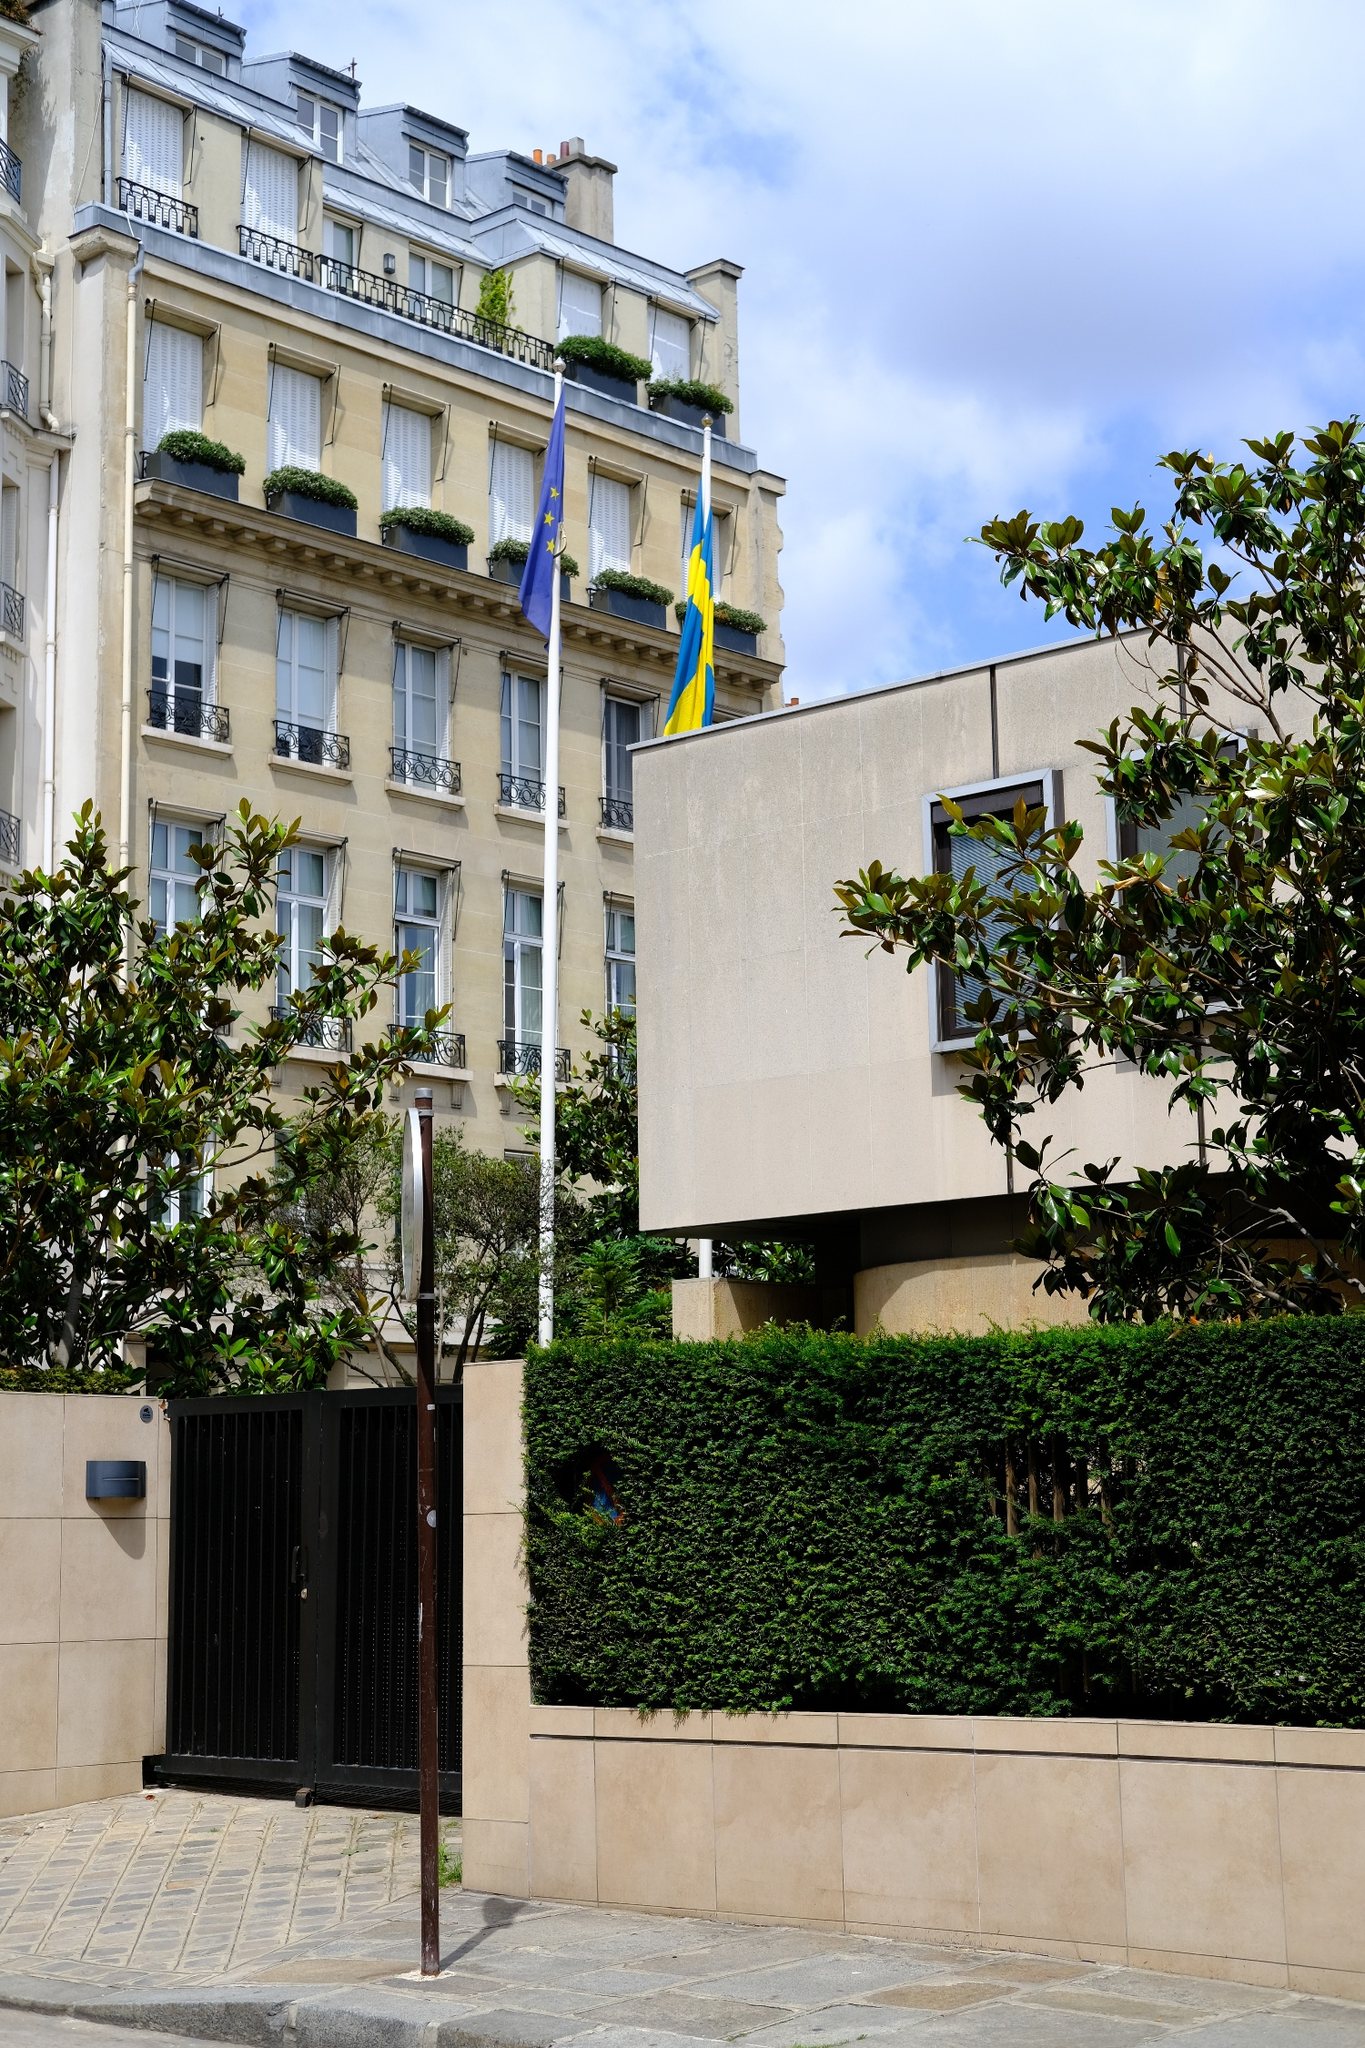Create a short, vivid story involving a character interacting with this building. Amelia had always been intrigued by the elegant beige building she passed on her way to the university every morning. Today, clutching a mysterious letter she found slipped under her door, she felt drawn to it more than ever. The building, always flanked by the fluttering European Union and Swedish flags, seemed to beckon her. As she approached the ornate gate, an elderly man with a twinkling eye greeted her as if he had known her all her life. He explained that she had been invited to join a clandestine society of historians and diplomats who met within these walls to preserve and uncover the lost secrets of European history. Amelia’s heart raced with a mix of fear and excitement as she stepped inside, instantly feeling the weight of centuries of untold stories and the promise of adventurous discoveries that awaited her. 